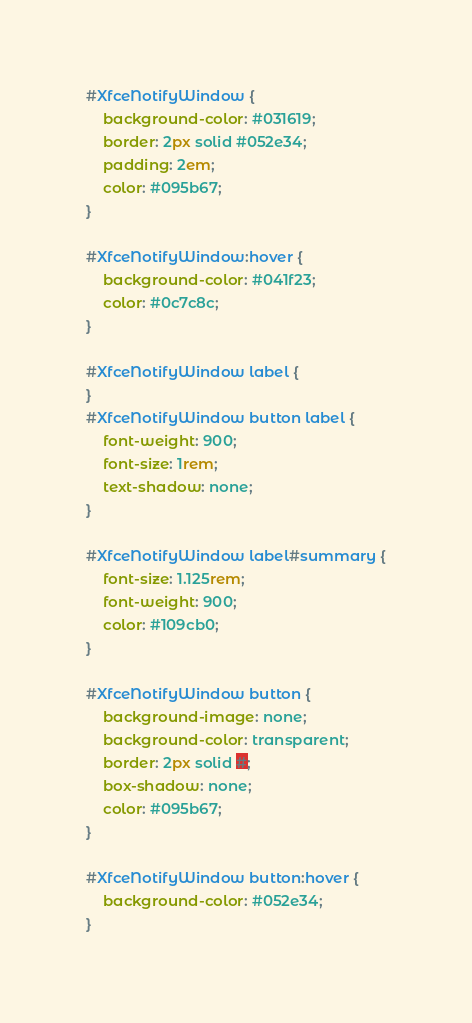Convert code to text. <code><loc_0><loc_0><loc_500><loc_500><_CSS_>#XfceNotifyWindow {
    background-color: #031619;
    border: 2px solid #052e34;
    padding: 2em;
    color: #095b67;
}

#XfceNotifyWindow:hover {
    background-color: #041f23;
    color: #0c7c8c;
}

#XfceNotifyWindow label {
}
#XfceNotifyWindow button label {
    font-weight: 900;
    font-size: 1rem;
    text-shadow: none;
}

#XfceNotifyWindow label#summary {
    font-size: 1.125rem;
    font-weight: 900;
    color: #109cb0;
}

#XfceNotifyWindow button {
    background-image: none;
    background-color: transparent;
    border: 2px solid #;
    box-shadow: none;
    color: #095b67;
}

#XfceNotifyWindow button:hover {
    background-color: #052e34;
}
</code> 